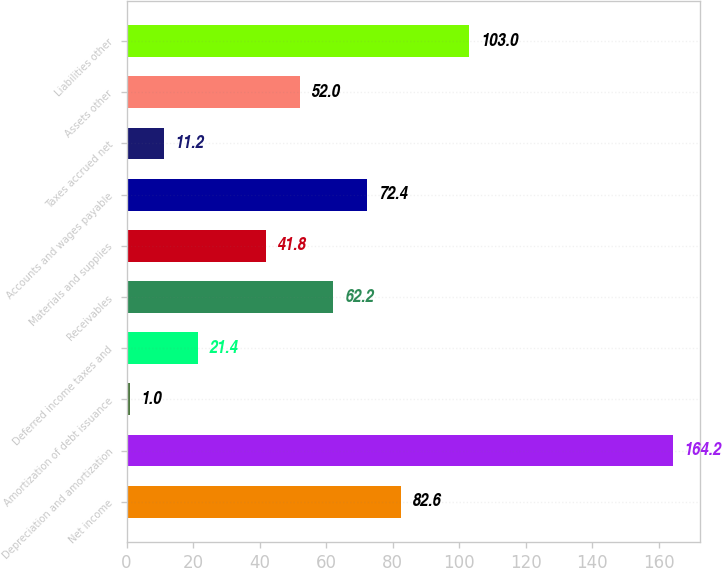<chart> <loc_0><loc_0><loc_500><loc_500><bar_chart><fcel>Net income<fcel>Depreciation and amortization<fcel>Amortization of debt issuance<fcel>Deferred income taxes and<fcel>Receivables<fcel>Materials and supplies<fcel>Accounts and wages payable<fcel>Taxes accrued net<fcel>Assets other<fcel>Liabilities other<nl><fcel>82.6<fcel>164.2<fcel>1<fcel>21.4<fcel>62.2<fcel>41.8<fcel>72.4<fcel>11.2<fcel>52<fcel>103<nl></chart> 